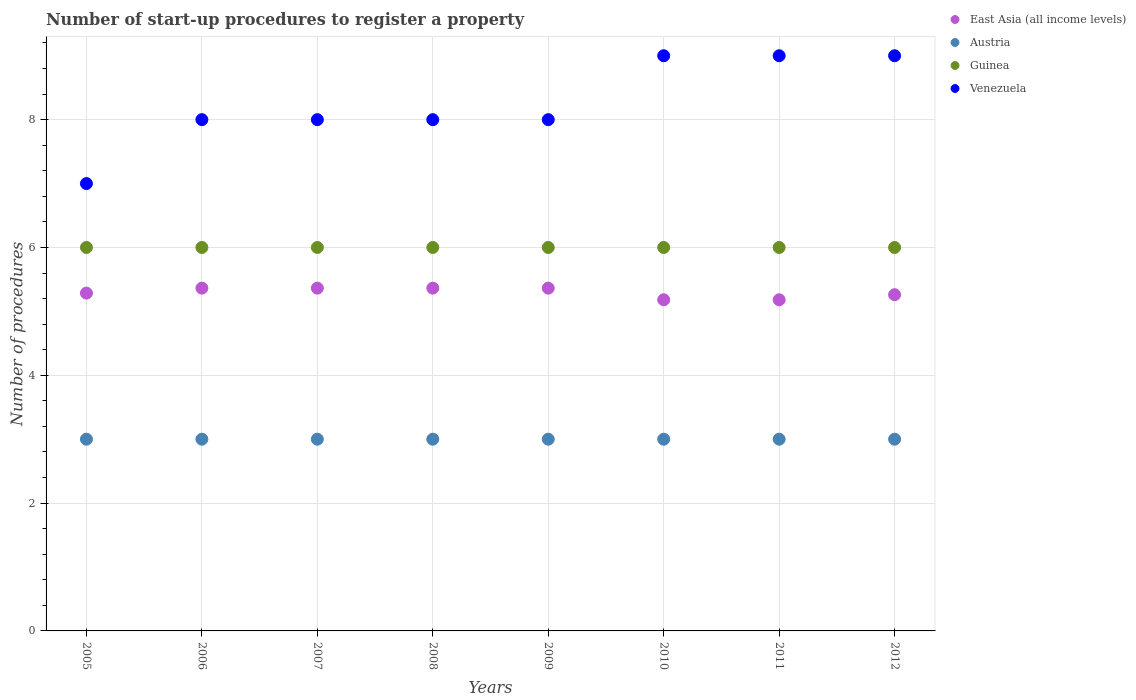How many different coloured dotlines are there?
Keep it short and to the point. 4. What is the number of procedures required to register a property in Austria in 2009?
Ensure brevity in your answer.  3. Across all years, what is the maximum number of procedures required to register a property in East Asia (all income levels)?
Your answer should be compact. 5.36. Across all years, what is the minimum number of procedures required to register a property in Venezuela?
Offer a very short reply. 7. In which year was the number of procedures required to register a property in East Asia (all income levels) minimum?
Provide a succinct answer. 2010. What is the total number of procedures required to register a property in Guinea in the graph?
Offer a very short reply. 48. What is the difference between the number of procedures required to register a property in Venezuela in 2008 and the number of procedures required to register a property in Guinea in 2012?
Your answer should be compact. 2. What is the average number of procedures required to register a property in East Asia (all income levels) per year?
Keep it short and to the point. 5.3. In the year 2006, what is the difference between the number of procedures required to register a property in Venezuela and number of procedures required to register a property in Guinea?
Your response must be concise. 2. In how many years, is the number of procedures required to register a property in East Asia (all income levels) greater than 1.6?
Offer a very short reply. 8. What is the difference between the highest and the second highest number of procedures required to register a property in Venezuela?
Make the answer very short. 0. What is the difference between the highest and the lowest number of procedures required to register a property in Austria?
Provide a succinct answer. 0. Is it the case that in every year, the sum of the number of procedures required to register a property in East Asia (all income levels) and number of procedures required to register a property in Guinea  is greater than the number of procedures required to register a property in Venezuela?
Make the answer very short. Yes. Is the number of procedures required to register a property in Austria strictly less than the number of procedures required to register a property in Venezuela over the years?
Offer a terse response. Yes. How many dotlines are there?
Make the answer very short. 4. Does the graph contain grids?
Ensure brevity in your answer.  Yes. Where does the legend appear in the graph?
Provide a succinct answer. Top right. How are the legend labels stacked?
Your answer should be very brief. Vertical. What is the title of the graph?
Give a very brief answer. Number of start-up procedures to register a property. What is the label or title of the Y-axis?
Your answer should be very brief. Number of procedures. What is the Number of procedures of East Asia (all income levels) in 2005?
Make the answer very short. 5.29. What is the Number of procedures of Guinea in 2005?
Provide a short and direct response. 6. What is the Number of procedures in East Asia (all income levels) in 2006?
Give a very brief answer. 5.36. What is the Number of procedures of Austria in 2006?
Offer a terse response. 3. What is the Number of procedures of Guinea in 2006?
Ensure brevity in your answer.  6. What is the Number of procedures in East Asia (all income levels) in 2007?
Offer a terse response. 5.36. What is the Number of procedures in Guinea in 2007?
Give a very brief answer. 6. What is the Number of procedures of East Asia (all income levels) in 2008?
Offer a very short reply. 5.36. What is the Number of procedures in Guinea in 2008?
Provide a short and direct response. 6. What is the Number of procedures in East Asia (all income levels) in 2009?
Give a very brief answer. 5.36. What is the Number of procedures in Austria in 2009?
Ensure brevity in your answer.  3. What is the Number of procedures of East Asia (all income levels) in 2010?
Your answer should be very brief. 5.18. What is the Number of procedures of East Asia (all income levels) in 2011?
Offer a terse response. 5.18. What is the Number of procedures in Austria in 2011?
Offer a very short reply. 3. What is the Number of procedures in Guinea in 2011?
Keep it short and to the point. 6. What is the Number of procedures of Venezuela in 2011?
Offer a very short reply. 9. What is the Number of procedures of East Asia (all income levels) in 2012?
Keep it short and to the point. 5.26. What is the Number of procedures of Austria in 2012?
Give a very brief answer. 3. What is the Number of procedures of Guinea in 2012?
Offer a very short reply. 6. Across all years, what is the maximum Number of procedures in East Asia (all income levels)?
Keep it short and to the point. 5.36. Across all years, what is the minimum Number of procedures in East Asia (all income levels)?
Provide a succinct answer. 5.18. Across all years, what is the minimum Number of procedures in Guinea?
Make the answer very short. 6. What is the total Number of procedures in East Asia (all income levels) in the graph?
Your answer should be very brief. 42.36. What is the total Number of procedures of Guinea in the graph?
Give a very brief answer. 48. What is the total Number of procedures in Venezuela in the graph?
Give a very brief answer. 66. What is the difference between the Number of procedures of East Asia (all income levels) in 2005 and that in 2006?
Offer a terse response. -0.08. What is the difference between the Number of procedures in Guinea in 2005 and that in 2006?
Give a very brief answer. 0. What is the difference between the Number of procedures of Venezuela in 2005 and that in 2006?
Your response must be concise. -1. What is the difference between the Number of procedures in East Asia (all income levels) in 2005 and that in 2007?
Give a very brief answer. -0.08. What is the difference between the Number of procedures of Austria in 2005 and that in 2007?
Offer a very short reply. 0. What is the difference between the Number of procedures of Venezuela in 2005 and that in 2007?
Offer a terse response. -1. What is the difference between the Number of procedures in East Asia (all income levels) in 2005 and that in 2008?
Offer a terse response. -0.08. What is the difference between the Number of procedures in Austria in 2005 and that in 2008?
Offer a very short reply. 0. What is the difference between the Number of procedures in Guinea in 2005 and that in 2008?
Offer a terse response. 0. What is the difference between the Number of procedures of Venezuela in 2005 and that in 2008?
Your answer should be compact. -1. What is the difference between the Number of procedures in East Asia (all income levels) in 2005 and that in 2009?
Your answer should be very brief. -0.08. What is the difference between the Number of procedures in Austria in 2005 and that in 2009?
Give a very brief answer. 0. What is the difference between the Number of procedures of Guinea in 2005 and that in 2009?
Give a very brief answer. 0. What is the difference between the Number of procedures in East Asia (all income levels) in 2005 and that in 2010?
Your answer should be very brief. 0.1. What is the difference between the Number of procedures in Austria in 2005 and that in 2010?
Provide a short and direct response. 0. What is the difference between the Number of procedures of Guinea in 2005 and that in 2010?
Ensure brevity in your answer.  0. What is the difference between the Number of procedures in East Asia (all income levels) in 2005 and that in 2011?
Your answer should be very brief. 0.1. What is the difference between the Number of procedures of Austria in 2005 and that in 2011?
Make the answer very short. 0. What is the difference between the Number of procedures in Venezuela in 2005 and that in 2011?
Offer a terse response. -2. What is the difference between the Number of procedures of East Asia (all income levels) in 2005 and that in 2012?
Offer a terse response. 0.02. What is the difference between the Number of procedures in Austria in 2005 and that in 2012?
Your answer should be compact. 0. What is the difference between the Number of procedures of Guinea in 2005 and that in 2012?
Offer a terse response. 0. What is the difference between the Number of procedures in Venezuela in 2005 and that in 2012?
Offer a terse response. -2. What is the difference between the Number of procedures in East Asia (all income levels) in 2006 and that in 2007?
Offer a terse response. 0. What is the difference between the Number of procedures in Austria in 2006 and that in 2007?
Your answer should be compact. 0. What is the difference between the Number of procedures in Guinea in 2006 and that in 2007?
Provide a succinct answer. 0. What is the difference between the Number of procedures of Venezuela in 2006 and that in 2007?
Offer a very short reply. 0. What is the difference between the Number of procedures in East Asia (all income levels) in 2006 and that in 2008?
Make the answer very short. 0. What is the difference between the Number of procedures of Austria in 2006 and that in 2008?
Ensure brevity in your answer.  0. What is the difference between the Number of procedures of Venezuela in 2006 and that in 2008?
Provide a succinct answer. 0. What is the difference between the Number of procedures in Austria in 2006 and that in 2009?
Offer a terse response. 0. What is the difference between the Number of procedures of Guinea in 2006 and that in 2009?
Make the answer very short. 0. What is the difference between the Number of procedures in East Asia (all income levels) in 2006 and that in 2010?
Your answer should be compact. 0.18. What is the difference between the Number of procedures of Austria in 2006 and that in 2010?
Give a very brief answer. 0. What is the difference between the Number of procedures of Guinea in 2006 and that in 2010?
Make the answer very short. 0. What is the difference between the Number of procedures of Venezuela in 2006 and that in 2010?
Keep it short and to the point. -1. What is the difference between the Number of procedures in East Asia (all income levels) in 2006 and that in 2011?
Keep it short and to the point. 0.18. What is the difference between the Number of procedures of Venezuela in 2006 and that in 2011?
Your answer should be very brief. -1. What is the difference between the Number of procedures of East Asia (all income levels) in 2006 and that in 2012?
Ensure brevity in your answer.  0.1. What is the difference between the Number of procedures of Austria in 2006 and that in 2012?
Give a very brief answer. 0. What is the difference between the Number of procedures of Austria in 2007 and that in 2008?
Give a very brief answer. 0. What is the difference between the Number of procedures of Guinea in 2007 and that in 2008?
Your response must be concise. 0. What is the difference between the Number of procedures in Austria in 2007 and that in 2009?
Your answer should be compact. 0. What is the difference between the Number of procedures of Guinea in 2007 and that in 2009?
Your answer should be very brief. 0. What is the difference between the Number of procedures of Venezuela in 2007 and that in 2009?
Give a very brief answer. 0. What is the difference between the Number of procedures of East Asia (all income levels) in 2007 and that in 2010?
Give a very brief answer. 0.18. What is the difference between the Number of procedures of East Asia (all income levels) in 2007 and that in 2011?
Provide a succinct answer. 0.18. What is the difference between the Number of procedures in Austria in 2007 and that in 2011?
Make the answer very short. 0. What is the difference between the Number of procedures in Guinea in 2007 and that in 2011?
Your answer should be compact. 0. What is the difference between the Number of procedures in Venezuela in 2007 and that in 2011?
Provide a short and direct response. -1. What is the difference between the Number of procedures in East Asia (all income levels) in 2007 and that in 2012?
Ensure brevity in your answer.  0.1. What is the difference between the Number of procedures of Austria in 2007 and that in 2012?
Ensure brevity in your answer.  0. What is the difference between the Number of procedures of Guinea in 2007 and that in 2012?
Your answer should be very brief. 0. What is the difference between the Number of procedures of Venezuela in 2007 and that in 2012?
Your answer should be very brief. -1. What is the difference between the Number of procedures in East Asia (all income levels) in 2008 and that in 2009?
Your answer should be compact. 0. What is the difference between the Number of procedures in Austria in 2008 and that in 2009?
Ensure brevity in your answer.  0. What is the difference between the Number of procedures in Guinea in 2008 and that in 2009?
Your answer should be very brief. 0. What is the difference between the Number of procedures in Venezuela in 2008 and that in 2009?
Your answer should be very brief. 0. What is the difference between the Number of procedures in East Asia (all income levels) in 2008 and that in 2010?
Make the answer very short. 0.18. What is the difference between the Number of procedures of East Asia (all income levels) in 2008 and that in 2011?
Your response must be concise. 0.18. What is the difference between the Number of procedures in Austria in 2008 and that in 2011?
Provide a succinct answer. 0. What is the difference between the Number of procedures in Guinea in 2008 and that in 2011?
Offer a very short reply. 0. What is the difference between the Number of procedures of East Asia (all income levels) in 2008 and that in 2012?
Your answer should be compact. 0.1. What is the difference between the Number of procedures in Austria in 2008 and that in 2012?
Give a very brief answer. 0. What is the difference between the Number of procedures of Guinea in 2008 and that in 2012?
Your response must be concise. 0. What is the difference between the Number of procedures of Venezuela in 2008 and that in 2012?
Offer a terse response. -1. What is the difference between the Number of procedures in East Asia (all income levels) in 2009 and that in 2010?
Your answer should be compact. 0.18. What is the difference between the Number of procedures in Venezuela in 2009 and that in 2010?
Keep it short and to the point. -1. What is the difference between the Number of procedures of East Asia (all income levels) in 2009 and that in 2011?
Offer a very short reply. 0.18. What is the difference between the Number of procedures in Guinea in 2009 and that in 2011?
Your answer should be very brief. 0. What is the difference between the Number of procedures of Venezuela in 2009 and that in 2011?
Provide a succinct answer. -1. What is the difference between the Number of procedures in East Asia (all income levels) in 2009 and that in 2012?
Make the answer very short. 0.1. What is the difference between the Number of procedures of Austria in 2009 and that in 2012?
Your answer should be very brief. 0. What is the difference between the Number of procedures of Venezuela in 2009 and that in 2012?
Your answer should be compact. -1. What is the difference between the Number of procedures in East Asia (all income levels) in 2010 and that in 2011?
Your answer should be compact. 0. What is the difference between the Number of procedures of East Asia (all income levels) in 2010 and that in 2012?
Provide a short and direct response. -0.08. What is the difference between the Number of procedures in Guinea in 2010 and that in 2012?
Offer a very short reply. 0. What is the difference between the Number of procedures of East Asia (all income levels) in 2011 and that in 2012?
Your response must be concise. -0.08. What is the difference between the Number of procedures of Venezuela in 2011 and that in 2012?
Provide a succinct answer. 0. What is the difference between the Number of procedures in East Asia (all income levels) in 2005 and the Number of procedures in Austria in 2006?
Offer a terse response. 2.29. What is the difference between the Number of procedures of East Asia (all income levels) in 2005 and the Number of procedures of Guinea in 2006?
Give a very brief answer. -0.71. What is the difference between the Number of procedures in East Asia (all income levels) in 2005 and the Number of procedures in Venezuela in 2006?
Make the answer very short. -2.71. What is the difference between the Number of procedures of East Asia (all income levels) in 2005 and the Number of procedures of Austria in 2007?
Offer a terse response. 2.29. What is the difference between the Number of procedures of East Asia (all income levels) in 2005 and the Number of procedures of Guinea in 2007?
Keep it short and to the point. -0.71. What is the difference between the Number of procedures in East Asia (all income levels) in 2005 and the Number of procedures in Venezuela in 2007?
Make the answer very short. -2.71. What is the difference between the Number of procedures of Austria in 2005 and the Number of procedures of Venezuela in 2007?
Offer a very short reply. -5. What is the difference between the Number of procedures of Guinea in 2005 and the Number of procedures of Venezuela in 2007?
Offer a terse response. -2. What is the difference between the Number of procedures in East Asia (all income levels) in 2005 and the Number of procedures in Austria in 2008?
Give a very brief answer. 2.29. What is the difference between the Number of procedures of East Asia (all income levels) in 2005 and the Number of procedures of Guinea in 2008?
Give a very brief answer. -0.71. What is the difference between the Number of procedures in East Asia (all income levels) in 2005 and the Number of procedures in Venezuela in 2008?
Make the answer very short. -2.71. What is the difference between the Number of procedures of Austria in 2005 and the Number of procedures of Guinea in 2008?
Give a very brief answer. -3. What is the difference between the Number of procedures of Austria in 2005 and the Number of procedures of Venezuela in 2008?
Keep it short and to the point. -5. What is the difference between the Number of procedures of East Asia (all income levels) in 2005 and the Number of procedures of Austria in 2009?
Provide a short and direct response. 2.29. What is the difference between the Number of procedures of East Asia (all income levels) in 2005 and the Number of procedures of Guinea in 2009?
Offer a very short reply. -0.71. What is the difference between the Number of procedures in East Asia (all income levels) in 2005 and the Number of procedures in Venezuela in 2009?
Make the answer very short. -2.71. What is the difference between the Number of procedures in Austria in 2005 and the Number of procedures in Venezuela in 2009?
Keep it short and to the point. -5. What is the difference between the Number of procedures in Guinea in 2005 and the Number of procedures in Venezuela in 2009?
Your answer should be very brief. -2. What is the difference between the Number of procedures of East Asia (all income levels) in 2005 and the Number of procedures of Austria in 2010?
Ensure brevity in your answer.  2.29. What is the difference between the Number of procedures in East Asia (all income levels) in 2005 and the Number of procedures in Guinea in 2010?
Make the answer very short. -0.71. What is the difference between the Number of procedures of East Asia (all income levels) in 2005 and the Number of procedures of Venezuela in 2010?
Provide a succinct answer. -3.71. What is the difference between the Number of procedures in East Asia (all income levels) in 2005 and the Number of procedures in Austria in 2011?
Offer a terse response. 2.29. What is the difference between the Number of procedures in East Asia (all income levels) in 2005 and the Number of procedures in Guinea in 2011?
Keep it short and to the point. -0.71. What is the difference between the Number of procedures of East Asia (all income levels) in 2005 and the Number of procedures of Venezuela in 2011?
Make the answer very short. -3.71. What is the difference between the Number of procedures in Austria in 2005 and the Number of procedures in Guinea in 2011?
Offer a terse response. -3. What is the difference between the Number of procedures of Guinea in 2005 and the Number of procedures of Venezuela in 2011?
Your answer should be compact. -3. What is the difference between the Number of procedures in East Asia (all income levels) in 2005 and the Number of procedures in Austria in 2012?
Make the answer very short. 2.29. What is the difference between the Number of procedures in East Asia (all income levels) in 2005 and the Number of procedures in Guinea in 2012?
Make the answer very short. -0.71. What is the difference between the Number of procedures of East Asia (all income levels) in 2005 and the Number of procedures of Venezuela in 2012?
Your response must be concise. -3.71. What is the difference between the Number of procedures of East Asia (all income levels) in 2006 and the Number of procedures of Austria in 2007?
Offer a very short reply. 2.36. What is the difference between the Number of procedures in East Asia (all income levels) in 2006 and the Number of procedures in Guinea in 2007?
Your answer should be compact. -0.64. What is the difference between the Number of procedures in East Asia (all income levels) in 2006 and the Number of procedures in Venezuela in 2007?
Provide a short and direct response. -2.64. What is the difference between the Number of procedures in Guinea in 2006 and the Number of procedures in Venezuela in 2007?
Your answer should be very brief. -2. What is the difference between the Number of procedures in East Asia (all income levels) in 2006 and the Number of procedures in Austria in 2008?
Keep it short and to the point. 2.36. What is the difference between the Number of procedures of East Asia (all income levels) in 2006 and the Number of procedures of Guinea in 2008?
Give a very brief answer. -0.64. What is the difference between the Number of procedures in East Asia (all income levels) in 2006 and the Number of procedures in Venezuela in 2008?
Keep it short and to the point. -2.64. What is the difference between the Number of procedures in East Asia (all income levels) in 2006 and the Number of procedures in Austria in 2009?
Your answer should be very brief. 2.36. What is the difference between the Number of procedures of East Asia (all income levels) in 2006 and the Number of procedures of Guinea in 2009?
Provide a short and direct response. -0.64. What is the difference between the Number of procedures of East Asia (all income levels) in 2006 and the Number of procedures of Venezuela in 2009?
Keep it short and to the point. -2.64. What is the difference between the Number of procedures in Guinea in 2006 and the Number of procedures in Venezuela in 2009?
Make the answer very short. -2. What is the difference between the Number of procedures of East Asia (all income levels) in 2006 and the Number of procedures of Austria in 2010?
Your response must be concise. 2.36. What is the difference between the Number of procedures of East Asia (all income levels) in 2006 and the Number of procedures of Guinea in 2010?
Give a very brief answer. -0.64. What is the difference between the Number of procedures in East Asia (all income levels) in 2006 and the Number of procedures in Venezuela in 2010?
Make the answer very short. -3.64. What is the difference between the Number of procedures of Austria in 2006 and the Number of procedures of Venezuela in 2010?
Keep it short and to the point. -6. What is the difference between the Number of procedures in East Asia (all income levels) in 2006 and the Number of procedures in Austria in 2011?
Give a very brief answer. 2.36. What is the difference between the Number of procedures of East Asia (all income levels) in 2006 and the Number of procedures of Guinea in 2011?
Offer a terse response. -0.64. What is the difference between the Number of procedures of East Asia (all income levels) in 2006 and the Number of procedures of Venezuela in 2011?
Provide a succinct answer. -3.64. What is the difference between the Number of procedures of Austria in 2006 and the Number of procedures of Venezuela in 2011?
Provide a succinct answer. -6. What is the difference between the Number of procedures in Guinea in 2006 and the Number of procedures in Venezuela in 2011?
Keep it short and to the point. -3. What is the difference between the Number of procedures in East Asia (all income levels) in 2006 and the Number of procedures in Austria in 2012?
Offer a very short reply. 2.36. What is the difference between the Number of procedures in East Asia (all income levels) in 2006 and the Number of procedures in Guinea in 2012?
Offer a terse response. -0.64. What is the difference between the Number of procedures of East Asia (all income levels) in 2006 and the Number of procedures of Venezuela in 2012?
Offer a terse response. -3.64. What is the difference between the Number of procedures in Austria in 2006 and the Number of procedures in Guinea in 2012?
Your answer should be very brief. -3. What is the difference between the Number of procedures in Guinea in 2006 and the Number of procedures in Venezuela in 2012?
Give a very brief answer. -3. What is the difference between the Number of procedures in East Asia (all income levels) in 2007 and the Number of procedures in Austria in 2008?
Make the answer very short. 2.36. What is the difference between the Number of procedures in East Asia (all income levels) in 2007 and the Number of procedures in Guinea in 2008?
Your answer should be compact. -0.64. What is the difference between the Number of procedures in East Asia (all income levels) in 2007 and the Number of procedures in Venezuela in 2008?
Offer a very short reply. -2.64. What is the difference between the Number of procedures of Austria in 2007 and the Number of procedures of Guinea in 2008?
Your response must be concise. -3. What is the difference between the Number of procedures of Austria in 2007 and the Number of procedures of Venezuela in 2008?
Your response must be concise. -5. What is the difference between the Number of procedures in East Asia (all income levels) in 2007 and the Number of procedures in Austria in 2009?
Ensure brevity in your answer.  2.36. What is the difference between the Number of procedures in East Asia (all income levels) in 2007 and the Number of procedures in Guinea in 2009?
Provide a succinct answer. -0.64. What is the difference between the Number of procedures in East Asia (all income levels) in 2007 and the Number of procedures in Venezuela in 2009?
Offer a terse response. -2.64. What is the difference between the Number of procedures of Austria in 2007 and the Number of procedures of Guinea in 2009?
Offer a terse response. -3. What is the difference between the Number of procedures of Austria in 2007 and the Number of procedures of Venezuela in 2009?
Offer a terse response. -5. What is the difference between the Number of procedures in Guinea in 2007 and the Number of procedures in Venezuela in 2009?
Give a very brief answer. -2. What is the difference between the Number of procedures in East Asia (all income levels) in 2007 and the Number of procedures in Austria in 2010?
Keep it short and to the point. 2.36. What is the difference between the Number of procedures in East Asia (all income levels) in 2007 and the Number of procedures in Guinea in 2010?
Provide a succinct answer. -0.64. What is the difference between the Number of procedures in East Asia (all income levels) in 2007 and the Number of procedures in Venezuela in 2010?
Your answer should be compact. -3.64. What is the difference between the Number of procedures in Austria in 2007 and the Number of procedures in Venezuela in 2010?
Make the answer very short. -6. What is the difference between the Number of procedures of Guinea in 2007 and the Number of procedures of Venezuela in 2010?
Offer a terse response. -3. What is the difference between the Number of procedures of East Asia (all income levels) in 2007 and the Number of procedures of Austria in 2011?
Keep it short and to the point. 2.36. What is the difference between the Number of procedures in East Asia (all income levels) in 2007 and the Number of procedures in Guinea in 2011?
Keep it short and to the point. -0.64. What is the difference between the Number of procedures of East Asia (all income levels) in 2007 and the Number of procedures of Venezuela in 2011?
Give a very brief answer. -3.64. What is the difference between the Number of procedures in Austria in 2007 and the Number of procedures in Guinea in 2011?
Offer a very short reply. -3. What is the difference between the Number of procedures of Austria in 2007 and the Number of procedures of Venezuela in 2011?
Offer a terse response. -6. What is the difference between the Number of procedures in East Asia (all income levels) in 2007 and the Number of procedures in Austria in 2012?
Your answer should be compact. 2.36. What is the difference between the Number of procedures in East Asia (all income levels) in 2007 and the Number of procedures in Guinea in 2012?
Make the answer very short. -0.64. What is the difference between the Number of procedures of East Asia (all income levels) in 2007 and the Number of procedures of Venezuela in 2012?
Provide a succinct answer. -3.64. What is the difference between the Number of procedures in Austria in 2007 and the Number of procedures in Guinea in 2012?
Your answer should be compact. -3. What is the difference between the Number of procedures of Guinea in 2007 and the Number of procedures of Venezuela in 2012?
Make the answer very short. -3. What is the difference between the Number of procedures in East Asia (all income levels) in 2008 and the Number of procedures in Austria in 2009?
Your answer should be very brief. 2.36. What is the difference between the Number of procedures in East Asia (all income levels) in 2008 and the Number of procedures in Guinea in 2009?
Ensure brevity in your answer.  -0.64. What is the difference between the Number of procedures of East Asia (all income levels) in 2008 and the Number of procedures of Venezuela in 2009?
Your answer should be very brief. -2.64. What is the difference between the Number of procedures in Austria in 2008 and the Number of procedures in Guinea in 2009?
Keep it short and to the point. -3. What is the difference between the Number of procedures in East Asia (all income levels) in 2008 and the Number of procedures in Austria in 2010?
Your response must be concise. 2.36. What is the difference between the Number of procedures in East Asia (all income levels) in 2008 and the Number of procedures in Guinea in 2010?
Make the answer very short. -0.64. What is the difference between the Number of procedures of East Asia (all income levels) in 2008 and the Number of procedures of Venezuela in 2010?
Your response must be concise. -3.64. What is the difference between the Number of procedures of Austria in 2008 and the Number of procedures of Venezuela in 2010?
Your answer should be compact. -6. What is the difference between the Number of procedures of Guinea in 2008 and the Number of procedures of Venezuela in 2010?
Your answer should be compact. -3. What is the difference between the Number of procedures in East Asia (all income levels) in 2008 and the Number of procedures in Austria in 2011?
Provide a succinct answer. 2.36. What is the difference between the Number of procedures of East Asia (all income levels) in 2008 and the Number of procedures of Guinea in 2011?
Keep it short and to the point. -0.64. What is the difference between the Number of procedures of East Asia (all income levels) in 2008 and the Number of procedures of Venezuela in 2011?
Keep it short and to the point. -3.64. What is the difference between the Number of procedures in Austria in 2008 and the Number of procedures in Guinea in 2011?
Your response must be concise. -3. What is the difference between the Number of procedures of Austria in 2008 and the Number of procedures of Venezuela in 2011?
Provide a succinct answer. -6. What is the difference between the Number of procedures in Guinea in 2008 and the Number of procedures in Venezuela in 2011?
Make the answer very short. -3. What is the difference between the Number of procedures in East Asia (all income levels) in 2008 and the Number of procedures in Austria in 2012?
Keep it short and to the point. 2.36. What is the difference between the Number of procedures in East Asia (all income levels) in 2008 and the Number of procedures in Guinea in 2012?
Offer a very short reply. -0.64. What is the difference between the Number of procedures in East Asia (all income levels) in 2008 and the Number of procedures in Venezuela in 2012?
Provide a short and direct response. -3.64. What is the difference between the Number of procedures in Austria in 2008 and the Number of procedures in Guinea in 2012?
Your answer should be compact. -3. What is the difference between the Number of procedures of Austria in 2008 and the Number of procedures of Venezuela in 2012?
Provide a succinct answer. -6. What is the difference between the Number of procedures of East Asia (all income levels) in 2009 and the Number of procedures of Austria in 2010?
Your answer should be very brief. 2.36. What is the difference between the Number of procedures of East Asia (all income levels) in 2009 and the Number of procedures of Guinea in 2010?
Give a very brief answer. -0.64. What is the difference between the Number of procedures of East Asia (all income levels) in 2009 and the Number of procedures of Venezuela in 2010?
Provide a short and direct response. -3.64. What is the difference between the Number of procedures in Austria in 2009 and the Number of procedures in Guinea in 2010?
Your answer should be compact. -3. What is the difference between the Number of procedures in Guinea in 2009 and the Number of procedures in Venezuela in 2010?
Your answer should be compact. -3. What is the difference between the Number of procedures in East Asia (all income levels) in 2009 and the Number of procedures in Austria in 2011?
Give a very brief answer. 2.36. What is the difference between the Number of procedures in East Asia (all income levels) in 2009 and the Number of procedures in Guinea in 2011?
Offer a terse response. -0.64. What is the difference between the Number of procedures of East Asia (all income levels) in 2009 and the Number of procedures of Venezuela in 2011?
Offer a terse response. -3.64. What is the difference between the Number of procedures of East Asia (all income levels) in 2009 and the Number of procedures of Austria in 2012?
Your answer should be very brief. 2.36. What is the difference between the Number of procedures in East Asia (all income levels) in 2009 and the Number of procedures in Guinea in 2012?
Offer a very short reply. -0.64. What is the difference between the Number of procedures of East Asia (all income levels) in 2009 and the Number of procedures of Venezuela in 2012?
Your answer should be compact. -3.64. What is the difference between the Number of procedures of Austria in 2009 and the Number of procedures of Guinea in 2012?
Your response must be concise. -3. What is the difference between the Number of procedures in East Asia (all income levels) in 2010 and the Number of procedures in Austria in 2011?
Your answer should be compact. 2.18. What is the difference between the Number of procedures of East Asia (all income levels) in 2010 and the Number of procedures of Guinea in 2011?
Offer a terse response. -0.82. What is the difference between the Number of procedures in East Asia (all income levels) in 2010 and the Number of procedures in Venezuela in 2011?
Offer a terse response. -3.82. What is the difference between the Number of procedures in Guinea in 2010 and the Number of procedures in Venezuela in 2011?
Your response must be concise. -3. What is the difference between the Number of procedures of East Asia (all income levels) in 2010 and the Number of procedures of Austria in 2012?
Make the answer very short. 2.18. What is the difference between the Number of procedures in East Asia (all income levels) in 2010 and the Number of procedures in Guinea in 2012?
Ensure brevity in your answer.  -0.82. What is the difference between the Number of procedures in East Asia (all income levels) in 2010 and the Number of procedures in Venezuela in 2012?
Ensure brevity in your answer.  -3.82. What is the difference between the Number of procedures in Austria in 2010 and the Number of procedures in Guinea in 2012?
Ensure brevity in your answer.  -3. What is the difference between the Number of procedures in Austria in 2010 and the Number of procedures in Venezuela in 2012?
Your answer should be compact. -6. What is the difference between the Number of procedures of East Asia (all income levels) in 2011 and the Number of procedures of Austria in 2012?
Your answer should be compact. 2.18. What is the difference between the Number of procedures in East Asia (all income levels) in 2011 and the Number of procedures in Guinea in 2012?
Offer a terse response. -0.82. What is the difference between the Number of procedures of East Asia (all income levels) in 2011 and the Number of procedures of Venezuela in 2012?
Your answer should be very brief. -3.82. What is the difference between the Number of procedures of Guinea in 2011 and the Number of procedures of Venezuela in 2012?
Ensure brevity in your answer.  -3. What is the average Number of procedures in East Asia (all income levels) per year?
Offer a terse response. 5.3. What is the average Number of procedures in Venezuela per year?
Your answer should be very brief. 8.25. In the year 2005, what is the difference between the Number of procedures of East Asia (all income levels) and Number of procedures of Austria?
Ensure brevity in your answer.  2.29. In the year 2005, what is the difference between the Number of procedures of East Asia (all income levels) and Number of procedures of Guinea?
Your answer should be compact. -0.71. In the year 2005, what is the difference between the Number of procedures in East Asia (all income levels) and Number of procedures in Venezuela?
Your response must be concise. -1.71. In the year 2005, what is the difference between the Number of procedures in Austria and Number of procedures in Guinea?
Provide a short and direct response. -3. In the year 2005, what is the difference between the Number of procedures of Austria and Number of procedures of Venezuela?
Your answer should be compact. -4. In the year 2005, what is the difference between the Number of procedures in Guinea and Number of procedures in Venezuela?
Offer a very short reply. -1. In the year 2006, what is the difference between the Number of procedures of East Asia (all income levels) and Number of procedures of Austria?
Your response must be concise. 2.36. In the year 2006, what is the difference between the Number of procedures of East Asia (all income levels) and Number of procedures of Guinea?
Offer a terse response. -0.64. In the year 2006, what is the difference between the Number of procedures of East Asia (all income levels) and Number of procedures of Venezuela?
Your answer should be compact. -2.64. In the year 2006, what is the difference between the Number of procedures of Austria and Number of procedures of Guinea?
Ensure brevity in your answer.  -3. In the year 2007, what is the difference between the Number of procedures of East Asia (all income levels) and Number of procedures of Austria?
Give a very brief answer. 2.36. In the year 2007, what is the difference between the Number of procedures in East Asia (all income levels) and Number of procedures in Guinea?
Provide a succinct answer. -0.64. In the year 2007, what is the difference between the Number of procedures of East Asia (all income levels) and Number of procedures of Venezuela?
Offer a very short reply. -2.64. In the year 2007, what is the difference between the Number of procedures in Austria and Number of procedures in Guinea?
Give a very brief answer. -3. In the year 2007, what is the difference between the Number of procedures in Austria and Number of procedures in Venezuela?
Your answer should be very brief. -5. In the year 2007, what is the difference between the Number of procedures in Guinea and Number of procedures in Venezuela?
Your answer should be very brief. -2. In the year 2008, what is the difference between the Number of procedures of East Asia (all income levels) and Number of procedures of Austria?
Keep it short and to the point. 2.36. In the year 2008, what is the difference between the Number of procedures of East Asia (all income levels) and Number of procedures of Guinea?
Give a very brief answer. -0.64. In the year 2008, what is the difference between the Number of procedures in East Asia (all income levels) and Number of procedures in Venezuela?
Offer a terse response. -2.64. In the year 2008, what is the difference between the Number of procedures in Austria and Number of procedures in Guinea?
Provide a short and direct response. -3. In the year 2008, what is the difference between the Number of procedures of Austria and Number of procedures of Venezuela?
Provide a succinct answer. -5. In the year 2008, what is the difference between the Number of procedures of Guinea and Number of procedures of Venezuela?
Provide a succinct answer. -2. In the year 2009, what is the difference between the Number of procedures in East Asia (all income levels) and Number of procedures in Austria?
Offer a very short reply. 2.36. In the year 2009, what is the difference between the Number of procedures in East Asia (all income levels) and Number of procedures in Guinea?
Offer a very short reply. -0.64. In the year 2009, what is the difference between the Number of procedures of East Asia (all income levels) and Number of procedures of Venezuela?
Give a very brief answer. -2.64. In the year 2009, what is the difference between the Number of procedures in Austria and Number of procedures in Venezuela?
Give a very brief answer. -5. In the year 2009, what is the difference between the Number of procedures of Guinea and Number of procedures of Venezuela?
Offer a terse response. -2. In the year 2010, what is the difference between the Number of procedures in East Asia (all income levels) and Number of procedures in Austria?
Make the answer very short. 2.18. In the year 2010, what is the difference between the Number of procedures in East Asia (all income levels) and Number of procedures in Guinea?
Keep it short and to the point. -0.82. In the year 2010, what is the difference between the Number of procedures in East Asia (all income levels) and Number of procedures in Venezuela?
Provide a succinct answer. -3.82. In the year 2010, what is the difference between the Number of procedures of Guinea and Number of procedures of Venezuela?
Your response must be concise. -3. In the year 2011, what is the difference between the Number of procedures of East Asia (all income levels) and Number of procedures of Austria?
Offer a very short reply. 2.18. In the year 2011, what is the difference between the Number of procedures in East Asia (all income levels) and Number of procedures in Guinea?
Your answer should be compact. -0.82. In the year 2011, what is the difference between the Number of procedures in East Asia (all income levels) and Number of procedures in Venezuela?
Give a very brief answer. -3.82. In the year 2011, what is the difference between the Number of procedures of Austria and Number of procedures of Guinea?
Keep it short and to the point. -3. In the year 2011, what is the difference between the Number of procedures in Austria and Number of procedures in Venezuela?
Make the answer very short. -6. In the year 2012, what is the difference between the Number of procedures of East Asia (all income levels) and Number of procedures of Austria?
Keep it short and to the point. 2.26. In the year 2012, what is the difference between the Number of procedures of East Asia (all income levels) and Number of procedures of Guinea?
Offer a terse response. -0.74. In the year 2012, what is the difference between the Number of procedures in East Asia (all income levels) and Number of procedures in Venezuela?
Provide a succinct answer. -3.74. In the year 2012, what is the difference between the Number of procedures of Austria and Number of procedures of Guinea?
Offer a terse response. -3. In the year 2012, what is the difference between the Number of procedures in Guinea and Number of procedures in Venezuela?
Your response must be concise. -3. What is the ratio of the Number of procedures of East Asia (all income levels) in 2005 to that in 2006?
Keep it short and to the point. 0.99. What is the ratio of the Number of procedures of Austria in 2005 to that in 2006?
Give a very brief answer. 1. What is the ratio of the Number of procedures of Guinea in 2005 to that in 2006?
Provide a succinct answer. 1. What is the ratio of the Number of procedures of East Asia (all income levels) in 2005 to that in 2007?
Provide a short and direct response. 0.99. What is the ratio of the Number of procedures in Austria in 2005 to that in 2007?
Offer a terse response. 1. What is the ratio of the Number of procedures of Venezuela in 2005 to that in 2007?
Offer a very short reply. 0.88. What is the ratio of the Number of procedures in East Asia (all income levels) in 2005 to that in 2008?
Ensure brevity in your answer.  0.99. What is the ratio of the Number of procedures of East Asia (all income levels) in 2005 to that in 2009?
Offer a terse response. 0.99. What is the ratio of the Number of procedures in Austria in 2005 to that in 2009?
Make the answer very short. 1. What is the ratio of the Number of procedures of East Asia (all income levels) in 2005 to that in 2010?
Offer a very short reply. 1.02. What is the ratio of the Number of procedures of Venezuela in 2005 to that in 2010?
Provide a short and direct response. 0.78. What is the ratio of the Number of procedures of East Asia (all income levels) in 2005 to that in 2011?
Offer a terse response. 1.02. What is the ratio of the Number of procedures of Austria in 2005 to that in 2011?
Provide a succinct answer. 1. What is the ratio of the Number of procedures in Venezuela in 2005 to that in 2011?
Provide a short and direct response. 0.78. What is the ratio of the Number of procedures in East Asia (all income levels) in 2005 to that in 2012?
Your answer should be very brief. 1. What is the ratio of the Number of procedures of Austria in 2005 to that in 2012?
Your answer should be compact. 1. What is the ratio of the Number of procedures in Guinea in 2005 to that in 2012?
Ensure brevity in your answer.  1. What is the ratio of the Number of procedures of Venezuela in 2005 to that in 2012?
Your response must be concise. 0.78. What is the ratio of the Number of procedures in Austria in 2006 to that in 2007?
Provide a succinct answer. 1. What is the ratio of the Number of procedures in Venezuela in 2006 to that in 2008?
Provide a succinct answer. 1. What is the ratio of the Number of procedures of Guinea in 2006 to that in 2009?
Offer a very short reply. 1. What is the ratio of the Number of procedures of East Asia (all income levels) in 2006 to that in 2010?
Keep it short and to the point. 1.04. What is the ratio of the Number of procedures in Guinea in 2006 to that in 2010?
Make the answer very short. 1. What is the ratio of the Number of procedures of Venezuela in 2006 to that in 2010?
Ensure brevity in your answer.  0.89. What is the ratio of the Number of procedures of East Asia (all income levels) in 2006 to that in 2011?
Your answer should be very brief. 1.04. What is the ratio of the Number of procedures of Austria in 2006 to that in 2011?
Keep it short and to the point. 1. What is the ratio of the Number of procedures of Guinea in 2006 to that in 2011?
Your response must be concise. 1. What is the ratio of the Number of procedures in Venezuela in 2006 to that in 2011?
Provide a succinct answer. 0.89. What is the ratio of the Number of procedures of East Asia (all income levels) in 2006 to that in 2012?
Provide a succinct answer. 1.02. What is the ratio of the Number of procedures in Guinea in 2006 to that in 2012?
Your answer should be compact. 1. What is the ratio of the Number of procedures of East Asia (all income levels) in 2007 to that in 2008?
Your answer should be very brief. 1. What is the ratio of the Number of procedures in Austria in 2007 to that in 2008?
Your answer should be very brief. 1. What is the ratio of the Number of procedures of Guinea in 2007 to that in 2008?
Keep it short and to the point. 1. What is the ratio of the Number of procedures in Venezuela in 2007 to that in 2008?
Offer a terse response. 1. What is the ratio of the Number of procedures in East Asia (all income levels) in 2007 to that in 2009?
Keep it short and to the point. 1. What is the ratio of the Number of procedures of Austria in 2007 to that in 2009?
Offer a very short reply. 1. What is the ratio of the Number of procedures in Venezuela in 2007 to that in 2009?
Make the answer very short. 1. What is the ratio of the Number of procedures in East Asia (all income levels) in 2007 to that in 2010?
Ensure brevity in your answer.  1.04. What is the ratio of the Number of procedures of Austria in 2007 to that in 2010?
Your answer should be very brief. 1. What is the ratio of the Number of procedures of Venezuela in 2007 to that in 2010?
Keep it short and to the point. 0.89. What is the ratio of the Number of procedures of East Asia (all income levels) in 2007 to that in 2011?
Make the answer very short. 1.04. What is the ratio of the Number of procedures of Austria in 2007 to that in 2011?
Your answer should be very brief. 1. What is the ratio of the Number of procedures of Venezuela in 2007 to that in 2011?
Your response must be concise. 0.89. What is the ratio of the Number of procedures in East Asia (all income levels) in 2007 to that in 2012?
Give a very brief answer. 1.02. What is the ratio of the Number of procedures of Austria in 2007 to that in 2012?
Your response must be concise. 1. What is the ratio of the Number of procedures of Venezuela in 2007 to that in 2012?
Your answer should be very brief. 0.89. What is the ratio of the Number of procedures of Guinea in 2008 to that in 2009?
Ensure brevity in your answer.  1. What is the ratio of the Number of procedures of East Asia (all income levels) in 2008 to that in 2010?
Your response must be concise. 1.04. What is the ratio of the Number of procedures in Guinea in 2008 to that in 2010?
Make the answer very short. 1. What is the ratio of the Number of procedures of East Asia (all income levels) in 2008 to that in 2011?
Your answer should be compact. 1.04. What is the ratio of the Number of procedures in East Asia (all income levels) in 2008 to that in 2012?
Offer a very short reply. 1.02. What is the ratio of the Number of procedures in Venezuela in 2008 to that in 2012?
Your answer should be very brief. 0.89. What is the ratio of the Number of procedures of East Asia (all income levels) in 2009 to that in 2010?
Make the answer very short. 1.04. What is the ratio of the Number of procedures of Austria in 2009 to that in 2010?
Keep it short and to the point. 1. What is the ratio of the Number of procedures of East Asia (all income levels) in 2009 to that in 2011?
Ensure brevity in your answer.  1.04. What is the ratio of the Number of procedures of Austria in 2009 to that in 2011?
Offer a terse response. 1. What is the ratio of the Number of procedures in Guinea in 2009 to that in 2011?
Offer a terse response. 1. What is the ratio of the Number of procedures of Venezuela in 2009 to that in 2011?
Your answer should be very brief. 0.89. What is the ratio of the Number of procedures in East Asia (all income levels) in 2009 to that in 2012?
Keep it short and to the point. 1.02. What is the ratio of the Number of procedures in Austria in 2009 to that in 2012?
Provide a succinct answer. 1. What is the ratio of the Number of procedures of Guinea in 2009 to that in 2012?
Give a very brief answer. 1. What is the ratio of the Number of procedures in Austria in 2010 to that in 2011?
Make the answer very short. 1. What is the ratio of the Number of procedures in Guinea in 2010 to that in 2011?
Keep it short and to the point. 1. What is the ratio of the Number of procedures in East Asia (all income levels) in 2010 to that in 2012?
Give a very brief answer. 0.98. What is the ratio of the Number of procedures in Austria in 2010 to that in 2012?
Your answer should be compact. 1. What is the ratio of the Number of procedures of East Asia (all income levels) in 2011 to that in 2012?
Your response must be concise. 0.98. What is the ratio of the Number of procedures in Guinea in 2011 to that in 2012?
Give a very brief answer. 1. What is the difference between the highest and the second highest Number of procedures of East Asia (all income levels)?
Provide a short and direct response. 0. What is the difference between the highest and the second highest Number of procedures of Guinea?
Your answer should be very brief. 0. What is the difference between the highest and the second highest Number of procedures of Venezuela?
Keep it short and to the point. 0. What is the difference between the highest and the lowest Number of procedures of East Asia (all income levels)?
Your answer should be very brief. 0.18. What is the difference between the highest and the lowest Number of procedures of Austria?
Keep it short and to the point. 0. What is the difference between the highest and the lowest Number of procedures in Guinea?
Your response must be concise. 0. What is the difference between the highest and the lowest Number of procedures of Venezuela?
Ensure brevity in your answer.  2. 